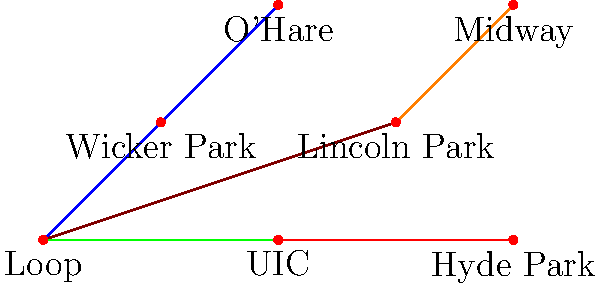Given the graph representation of Chicago's public transportation network, where nodes represent stations and edges represent direct train connections, what is the minimum number of transfers required to travel from O'Hare to Hyde Park? Additionally, calculate the betweenness centrality of the Loop station and explain its significance in the context of Chicago's public transit system. To solve this problem, we need to follow these steps:

1. Find the shortest path from O'Hare to Hyde Park:
   - O'Hare → Wicker Park → Loop → Hyde Park
   - This requires 2 transfers (at Wicker Park and Loop)

2. Calculate the betweenness centrality of the Loop station:
   a) Identify all shortest paths between pairs of nodes
   b) Count how many of these paths pass through the Loop
   c) Calculate the betweenness centrality

   For the Loop station:
   - It's on the shortest path for 15 out of 21 possible pairs of stations
   - Betweenness centrality = 15 / 21 ≈ 0.714

3. Significance of the Loop's high betweenness centrality:
   - It indicates that the Loop is a crucial transfer point in the network
   - It handles a large volume of passenger flow
   - It's vulnerable to disruptions, which could significantly impact the entire network
   - It suggests that improving capacity and efficiency at the Loop station could benefit the whole system

The minimum number of transfers from O'Hare to Hyde Park is 2, and the betweenness centrality of the Loop station is approximately 0.714, highlighting its importance as a central hub in Chicago's public transit system.
Answer: 2 transfers; Loop betweenness centrality ≈ 0.714 